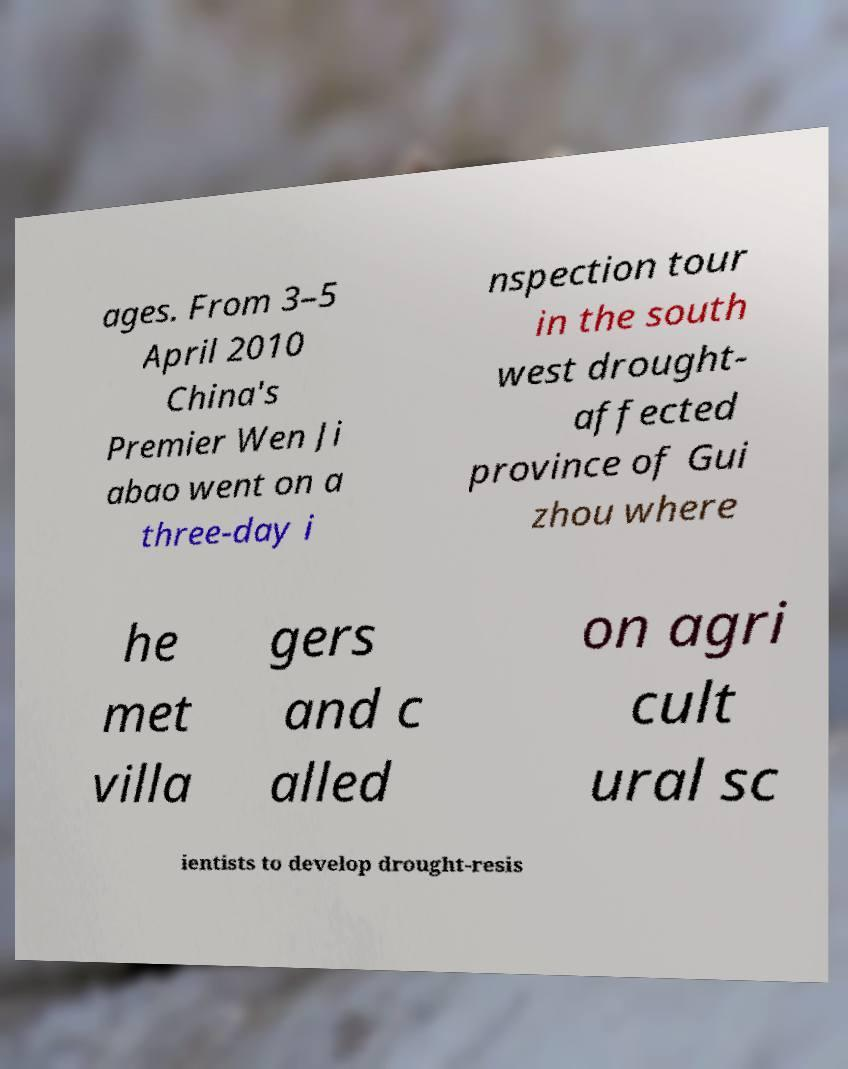Please identify and transcribe the text found in this image. ages. From 3–5 April 2010 China's Premier Wen Ji abao went on a three-day i nspection tour in the south west drought- affected province of Gui zhou where he met villa gers and c alled on agri cult ural sc ientists to develop drought-resis 